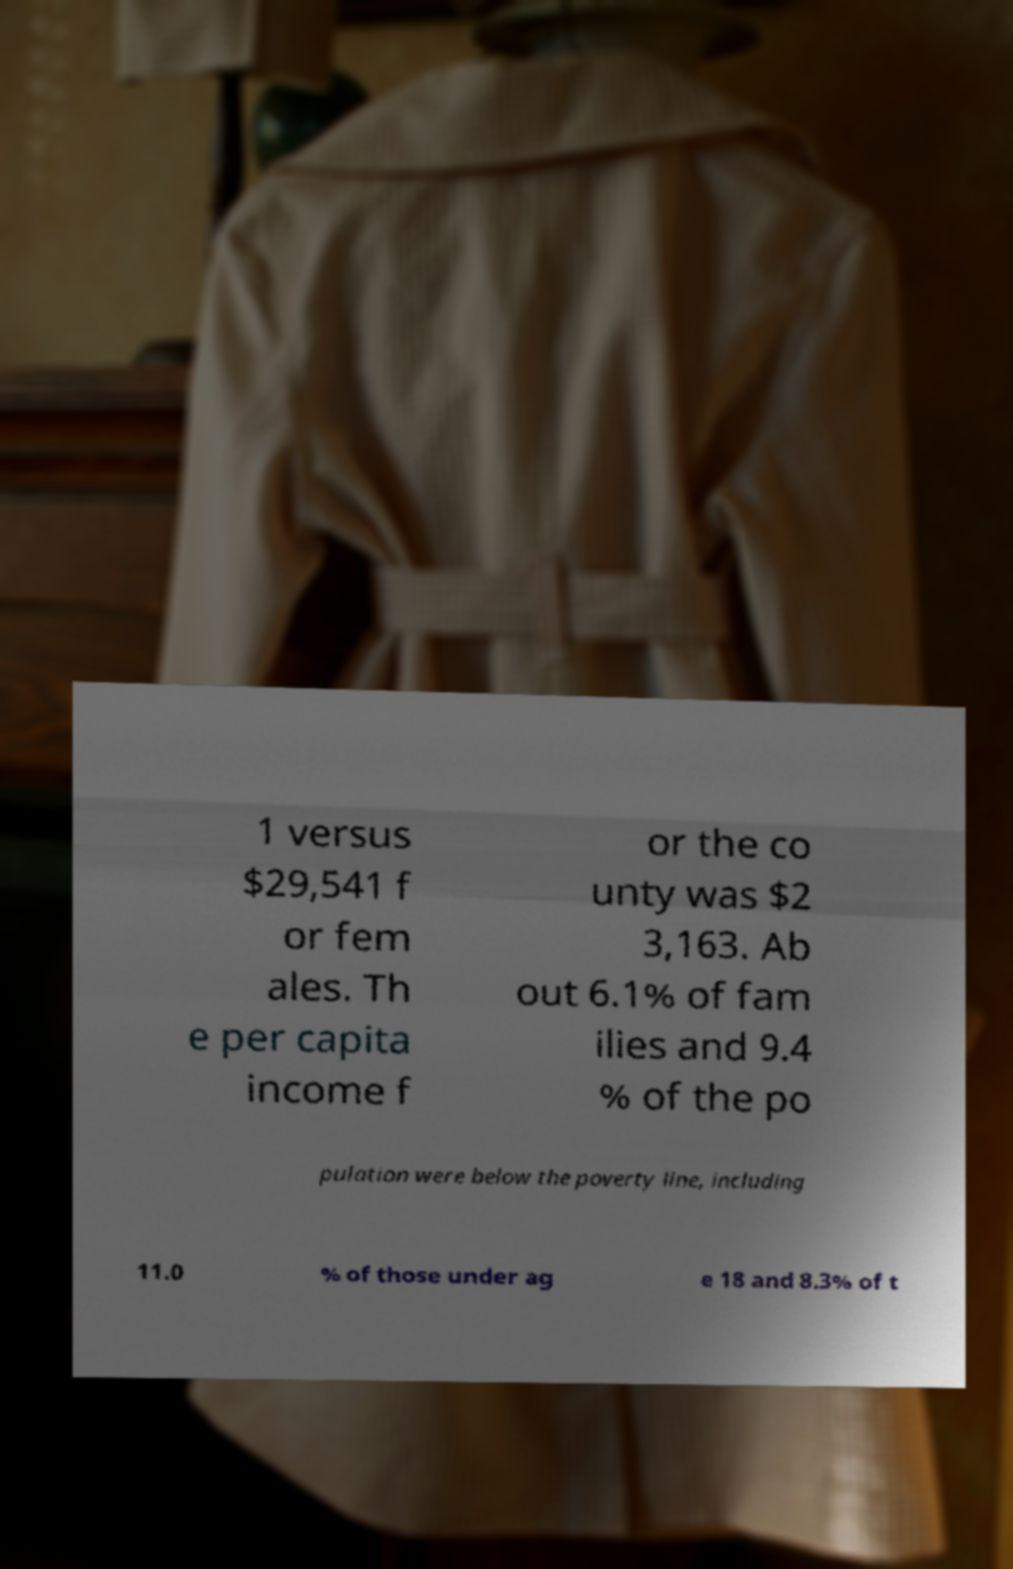Can you read and provide the text displayed in the image?This photo seems to have some interesting text. Can you extract and type it out for me? 1 versus $29,541 f or fem ales. Th e per capita income f or the co unty was $2 3,163. Ab out 6.1% of fam ilies and 9.4 % of the po pulation were below the poverty line, including 11.0 % of those under ag e 18 and 8.3% of t 